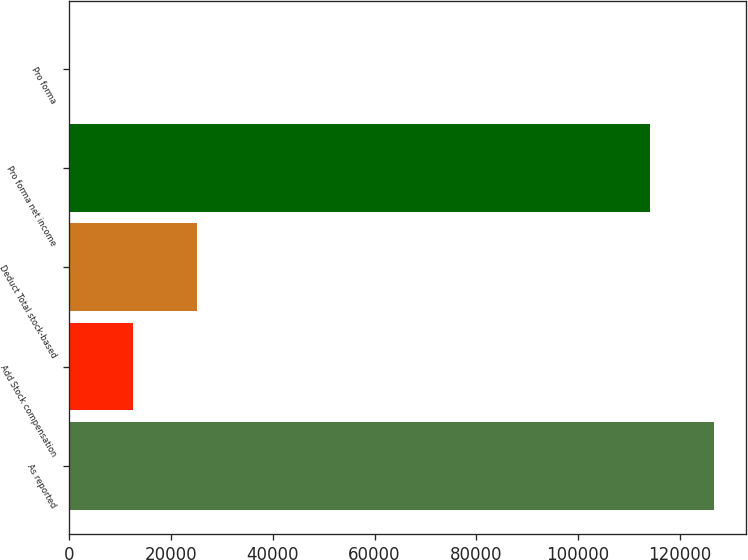Convert chart to OTSL. <chart><loc_0><loc_0><loc_500><loc_500><bar_chart><fcel>As reported<fcel>Add Stock compensation<fcel>Deduct Total stock-based<fcel>Pro forma net income<fcel>Pro forma<nl><fcel>126720<fcel>12553.7<fcel>25106<fcel>114168<fcel>1.45<nl></chart> 